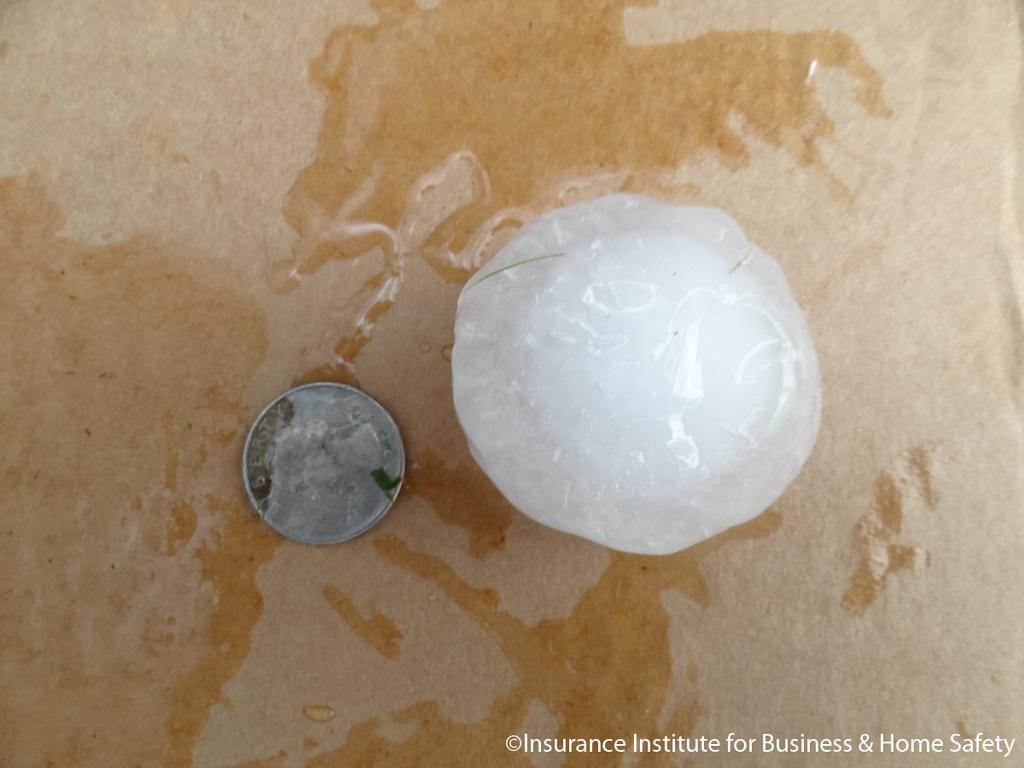What types of insurance does the institute cover?
Provide a short and direct response. Business & home safety. What does the text read above the head on the coin?
Make the answer very short. Unanswerable. 